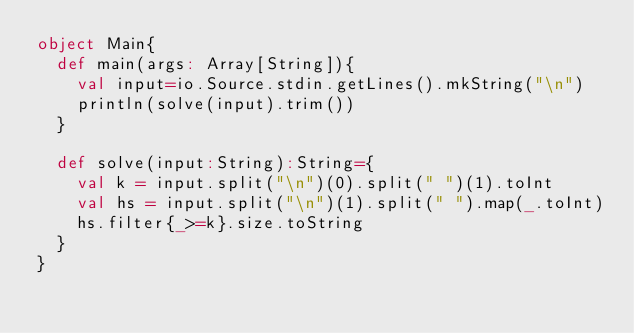<code> <loc_0><loc_0><loc_500><loc_500><_Scala_>object Main{
  def main(args: Array[String]){
    val input=io.Source.stdin.getLines().mkString("\n")
    println(solve(input).trim())
  }

  def solve(input:String):String={
    val k = input.split("\n")(0).split(" ")(1).toInt
    val hs = input.split("\n")(1).split(" ").map(_.toInt)
    hs.filter{_>=k}.size.toString
  }
}
</code> 